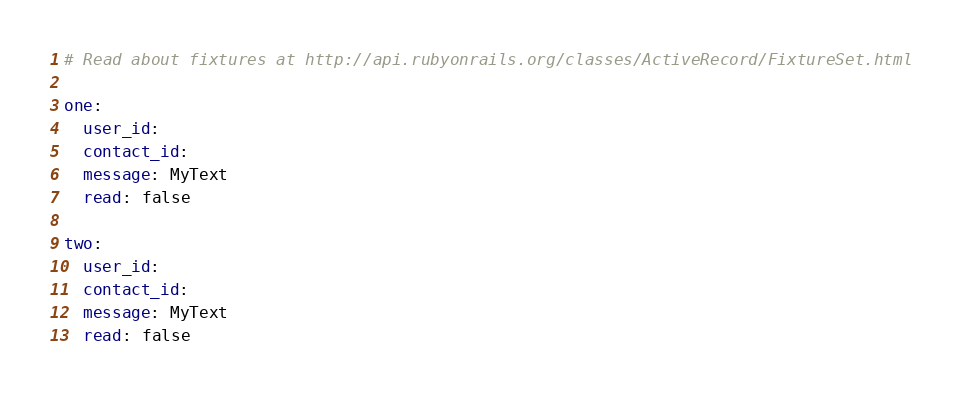Convert code to text. <code><loc_0><loc_0><loc_500><loc_500><_YAML_># Read about fixtures at http://api.rubyonrails.org/classes/ActiveRecord/FixtureSet.html

one:
  user_id: 
  contact_id: 
  message: MyText
  read: false

two:
  user_id: 
  contact_id: 
  message: MyText
  read: false
</code> 